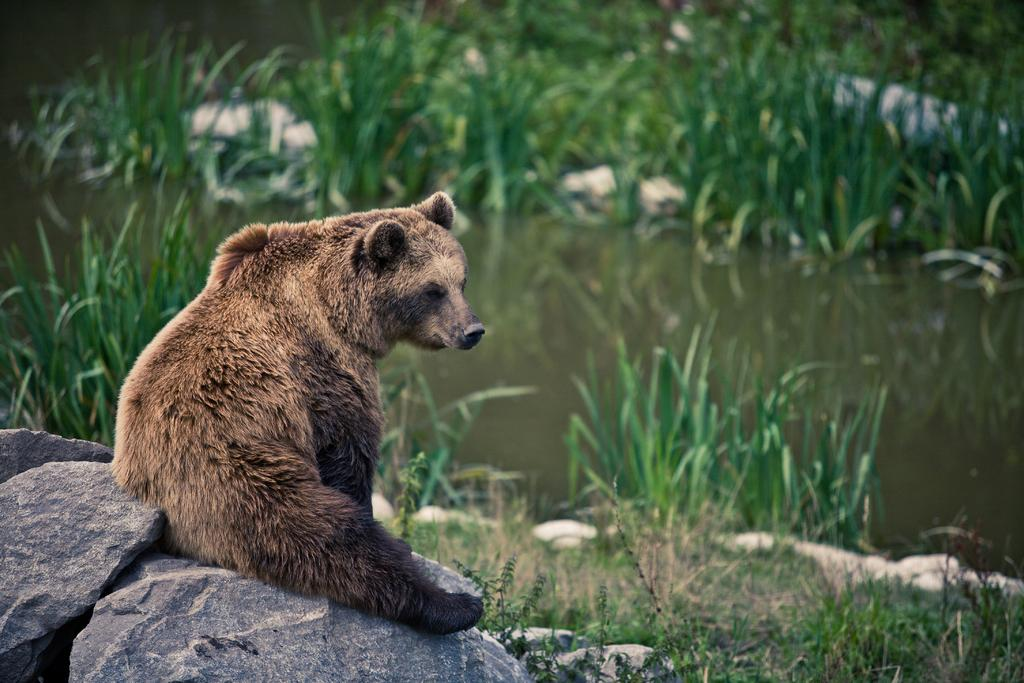What animal is present in the image? There is a bear in the image. What is the bear sitting on? The bear is sitting on a stone. What can be seen in the background of the image? There is water and grass visible in the background of the image. What type of cloth is the bear using to dry off in the image? There is no cloth present in the image, and the bear is not shown drying off. 